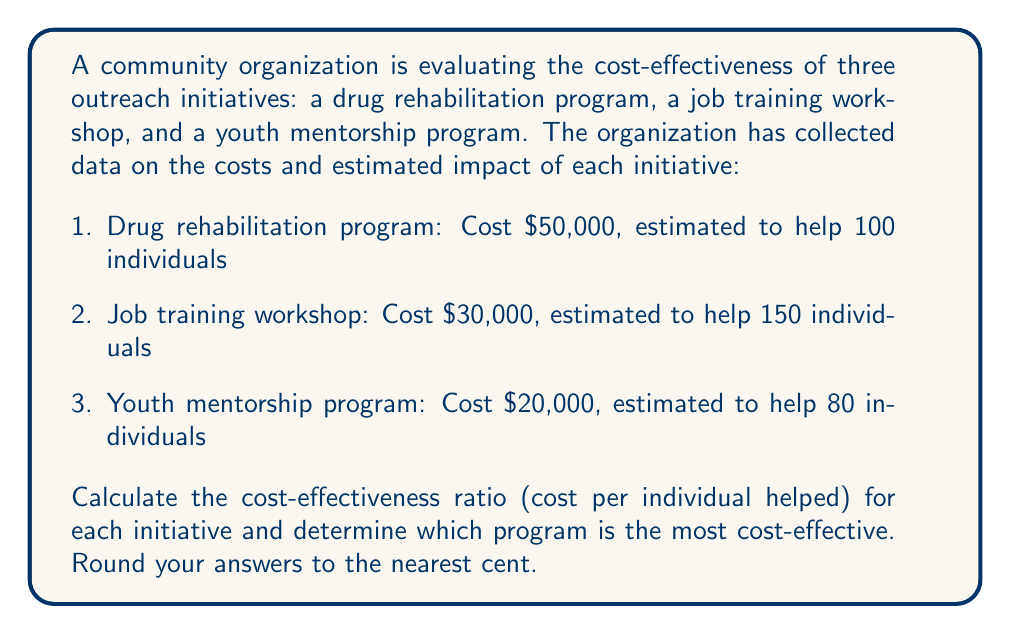Could you help me with this problem? To calculate the cost-effectiveness ratio for each initiative, we need to divide the total cost by the number of individuals helped. This will give us the cost per individual helped.

1. Drug rehabilitation program:
   $$ \text{Cost-effectiveness ratio} = \frac{\text{Total cost}}{\text{Number of individuals helped}} $$
   $$ = \frac{\$50,000}{100} = \$500.00 \text{ per individual} $$

2. Job training workshop:
   $$ \text{Cost-effectiveness ratio} = \frac{\$30,000}{150} = \$200.00 \text{ per individual} $$

3. Youth mentorship program:
   $$ \text{Cost-effectiveness ratio} = \frac{\$20,000}{80} = \$250.00 \text{ per individual} $$

To determine which program is the most cost-effective, we compare the cost-effectiveness ratios. The lower the ratio, the more cost-effective the program is.

Job training workshop: $200.00 per individual
Youth mentorship program: $250.00 per individual
Drug rehabilitation program: $500.00 per individual

Therefore, the job training workshop is the most cost-effective initiative, as it has the lowest cost per individual helped.
Answer: Job training workshop at $200.00 per individual 